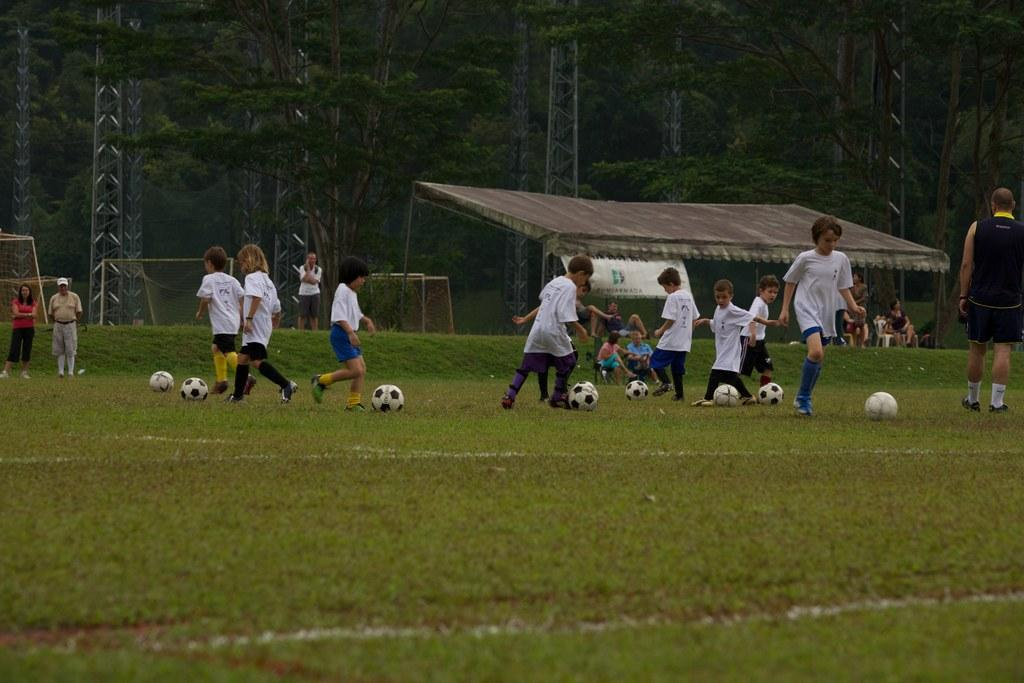What is happening in the image involving a group of children? The children are practicing football in the image. Where is the activity taking place? The location is a playground. What sport are the children engaged in? The children are practicing football. What type of creature can be seen wearing a sweater in the image? There is no creature wearing a sweater present in the image; it features a group of children practicing football at a playground. 